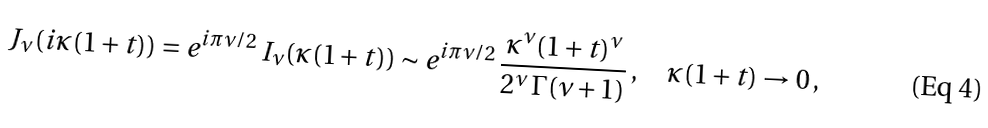Convert formula to latex. <formula><loc_0><loc_0><loc_500><loc_500>J _ { \nu } ( i \kappa ( 1 + t ) ) = e ^ { i \pi \nu / 2 } \, I _ { \nu } ( \kappa ( 1 + t ) ) \sim e ^ { i \pi \nu / 2 } \, \frac { \kappa ^ { \nu } ( 1 + t ) ^ { \nu } } { 2 ^ { \nu } \, \Gamma ( \nu + 1 ) } \, , \quad \kappa ( 1 + t ) \to 0 \, ,</formula> 